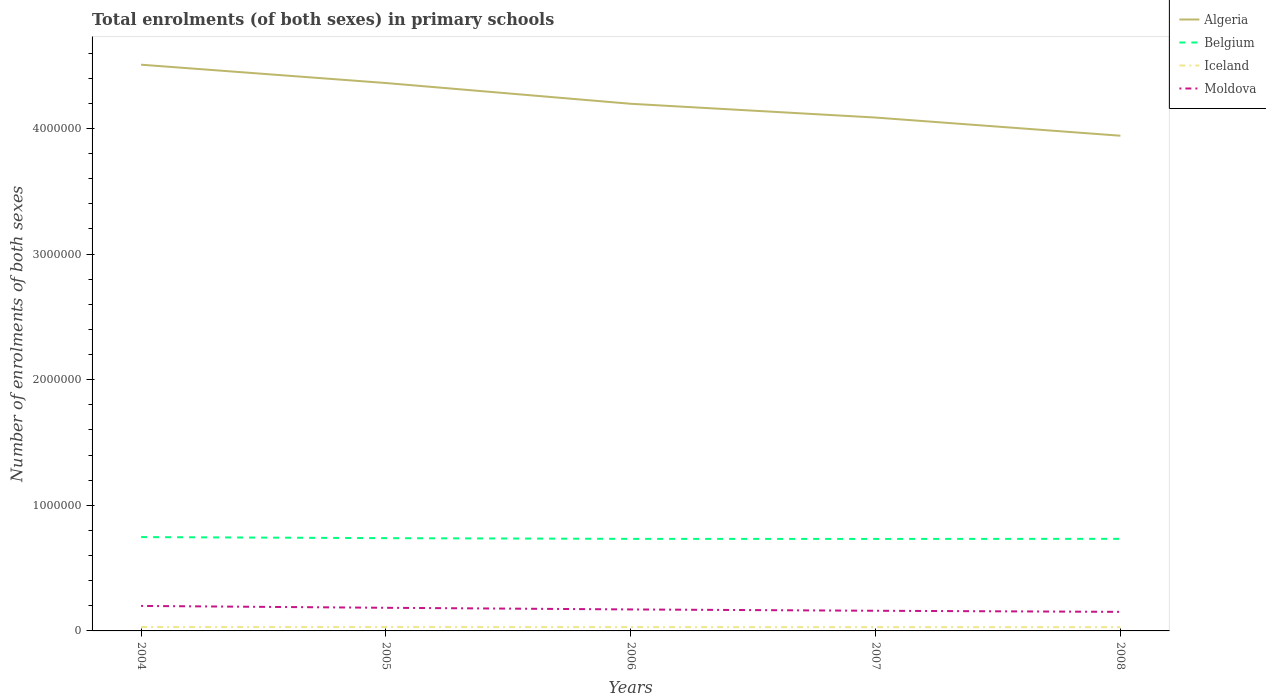Does the line corresponding to Iceland intersect with the line corresponding to Algeria?
Make the answer very short. No. Is the number of lines equal to the number of legend labels?
Keep it short and to the point. Yes. Across all years, what is the maximum number of enrolments in primary schools in Belgium?
Your answer should be very brief. 7.32e+05. In which year was the number of enrolments in primary schools in Belgium maximum?
Give a very brief answer. 2007. What is the total number of enrolments in primary schools in Iceland in the graph?
Your answer should be very brief. 1039. What is the difference between the highest and the second highest number of enrolments in primary schools in Belgium?
Offer a terse response. 1.47e+04. How many years are there in the graph?
Keep it short and to the point. 5. Are the values on the major ticks of Y-axis written in scientific E-notation?
Ensure brevity in your answer.  No. Does the graph contain any zero values?
Provide a succinct answer. No. Does the graph contain grids?
Your answer should be very brief. No. How many legend labels are there?
Keep it short and to the point. 4. How are the legend labels stacked?
Provide a succinct answer. Vertical. What is the title of the graph?
Give a very brief answer. Total enrolments (of both sexes) in primary schools. What is the label or title of the Y-axis?
Your answer should be compact. Number of enrolments of both sexes. What is the Number of enrolments of both sexes in Algeria in 2004?
Make the answer very short. 4.51e+06. What is the Number of enrolments of both sexes in Belgium in 2004?
Keep it short and to the point. 7.47e+05. What is the Number of enrolments of both sexes in Iceland in 2004?
Keep it short and to the point. 3.10e+04. What is the Number of enrolments of both sexes of Moldova in 2004?
Your answer should be very brief. 1.99e+05. What is the Number of enrolments of both sexes of Algeria in 2005?
Your response must be concise. 4.36e+06. What is the Number of enrolments of both sexes of Belgium in 2005?
Give a very brief answer. 7.39e+05. What is the Number of enrolments of both sexes in Iceland in 2005?
Make the answer very short. 3.08e+04. What is the Number of enrolments of both sexes in Moldova in 2005?
Give a very brief answer. 1.84e+05. What is the Number of enrolments of both sexes in Algeria in 2006?
Ensure brevity in your answer.  4.20e+06. What is the Number of enrolments of both sexes in Belgium in 2006?
Give a very brief answer. 7.33e+05. What is the Number of enrolments of both sexes in Iceland in 2006?
Provide a short and direct response. 3.04e+04. What is the Number of enrolments of both sexes in Moldova in 2006?
Your response must be concise. 1.71e+05. What is the Number of enrolments of both sexes in Algeria in 2007?
Give a very brief answer. 4.09e+06. What is the Number of enrolments of both sexes of Belgium in 2007?
Offer a terse response. 7.32e+05. What is the Number of enrolments of both sexes in Iceland in 2007?
Your answer should be very brief. 3.01e+04. What is the Number of enrolments of both sexes of Moldova in 2007?
Make the answer very short. 1.61e+05. What is the Number of enrolments of both sexes of Algeria in 2008?
Provide a short and direct response. 3.94e+06. What is the Number of enrolments of both sexes in Belgium in 2008?
Offer a terse response. 7.33e+05. What is the Number of enrolments of both sexes in Iceland in 2008?
Your answer should be compact. 2.99e+04. What is the Number of enrolments of both sexes of Moldova in 2008?
Offer a terse response. 1.52e+05. Across all years, what is the maximum Number of enrolments of both sexes in Algeria?
Ensure brevity in your answer.  4.51e+06. Across all years, what is the maximum Number of enrolments of both sexes in Belgium?
Keep it short and to the point. 7.47e+05. Across all years, what is the maximum Number of enrolments of both sexes of Iceland?
Your response must be concise. 3.10e+04. Across all years, what is the maximum Number of enrolments of both sexes of Moldova?
Keep it short and to the point. 1.99e+05. Across all years, what is the minimum Number of enrolments of both sexes of Algeria?
Your answer should be compact. 3.94e+06. Across all years, what is the minimum Number of enrolments of both sexes in Belgium?
Your answer should be very brief. 7.32e+05. Across all years, what is the minimum Number of enrolments of both sexes of Iceland?
Make the answer very short. 2.99e+04. Across all years, what is the minimum Number of enrolments of both sexes in Moldova?
Your response must be concise. 1.52e+05. What is the total Number of enrolments of both sexes in Algeria in the graph?
Ensure brevity in your answer.  2.11e+07. What is the total Number of enrolments of both sexes in Belgium in the graph?
Your answer should be very brief. 3.68e+06. What is the total Number of enrolments of both sexes of Iceland in the graph?
Your answer should be compact. 1.52e+05. What is the total Number of enrolments of both sexes of Moldova in the graph?
Your answer should be compact. 8.66e+05. What is the difference between the Number of enrolments of both sexes in Algeria in 2004 and that in 2005?
Ensure brevity in your answer.  1.46e+05. What is the difference between the Number of enrolments of both sexes of Belgium in 2004 and that in 2005?
Keep it short and to the point. 8531. What is the difference between the Number of enrolments of both sexes of Iceland in 2004 and that in 2005?
Offer a very short reply. 199. What is the difference between the Number of enrolments of both sexes of Moldova in 2004 and that in 2005?
Provide a short and direct response. 1.48e+04. What is the difference between the Number of enrolments of both sexes in Algeria in 2004 and that in 2006?
Provide a short and direct response. 3.11e+05. What is the difference between the Number of enrolments of both sexes in Belgium in 2004 and that in 2006?
Keep it short and to the point. 1.43e+04. What is the difference between the Number of enrolments of both sexes in Iceland in 2004 and that in 2006?
Your answer should be very brief. 563. What is the difference between the Number of enrolments of both sexes of Moldova in 2004 and that in 2006?
Offer a very short reply. 2.79e+04. What is the difference between the Number of enrolments of both sexes in Algeria in 2004 and that in 2007?
Offer a terse response. 4.21e+05. What is the difference between the Number of enrolments of both sexes of Belgium in 2004 and that in 2007?
Your response must be concise. 1.47e+04. What is the difference between the Number of enrolments of both sexes of Iceland in 2004 and that in 2007?
Give a very brief answer. 900. What is the difference between the Number of enrolments of both sexes in Moldova in 2004 and that in 2007?
Provide a succinct answer. 3.84e+04. What is the difference between the Number of enrolments of both sexes of Algeria in 2004 and that in 2008?
Offer a very short reply. 5.65e+05. What is the difference between the Number of enrolments of both sexes of Belgium in 2004 and that in 2008?
Keep it short and to the point. 1.41e+04. What is the difference between the Number of enrolments of both sexes of Iceland in 2004 and that in 2008?
Give a very brief answer. 1039. What is the difference between the Number of enrolments of both sexes in Moldova in 2004 and that in 2008?
Provide a short and direct response. 4.72e+04. What is the difference between the Number of enrolments of both sexes of Algeria in 2005 and that in 2006?
Offer a very short reply. 1.65e+05. What is the difference between the Number of enrolments of both sexes in Belgium in 2005 and that in 2006?
Your answer should be compact. 5772. What is the difference between the Number of enrolments of both sexes of Iceland in 2005 and that in 2006?
Provide a succinct answer. 364. What is the difference between the Number of enrolments of both sexes of Moldova in 2005 and that in 2006?
Make the answer very short. 1.31e+04. What is the difference between the Number of enrolments of both sexes of Algeria in 2005 and that in 2007?
Provide a succinct answer. 2.75e+05. What is the difference between the Number of enrolments of both sexes in Belgium in 2005 and that in 2007?
Keep it short and to the point. 6169. What is the difference between the Number of enrolments of both sexes of Iceland in 2005 and that in 2007?
Your answer should be very brief. 701. What is the difference between the Number of enrolments of both sexes in Moldova in 2005 and that in 2007?
Provide a succinct answer. 2.36e+04. What is the difference between the Number of enrolments of both sexes in Algeria in 2005 and that in 2008?
Ensure brevity in your answer.  4.20e+05. What is the difference between the Number of enrolments of both sexes in Belgium in 2005 and that in 2008?
Provide a short and direct response. 5528. What is the difference between the Number of enrolments of both sexes in Iceland in 2005 and that in 2008?
Give a very brief answer. 840. What is the difference between the Number of enrolments of both sexes in Moldova in 2005 and that in 2008?
Provide a short and direct response. 3.24e+04. What is the difference between the Number of enrolments of both sexes in Algeria in 2006 and that in 2007?
Your answer should be very brief. 1.10e+05. What is the difference between the Number of enrolments of both sexes in Belgium in 2006 and that in 2007?
Offer a terse response. 397. What is the difference between the Number of enrolments of both sexes of Iceland in 2006 and that in 2007?
Keep it short and to the point. 337. What is the difference between the Number of enrolments of both sexes in Moldova in 2006 and that in 2007?
Make the answer very short. 1.05e+04. What is the difference between the Number of enrolments of both sexes in Algeria in 2006 and that in 2008?
Provide a succinct answer. 2.54e+05. What is the difference between the Number of enrolments of both sexes of Belgium in 2006 and that in 2008?
Your answer should be very brief. -244. What is the difference between the Number of enrolments of both sexes in Iceland in 2006 and that in 2008?
Keep it short and to the point. 476. What is the difference between the Number of enrolments of both sexes in Moldova in 2006 and that in 2008?
Your answer should be compact. 1.93e+04. What is the difference between the Number of enrolments of both sexes in Algeria in 2007 and that in 2008?
Give a very brief answer. 1.45e+05. What is the difference between the Number of enrolments of both sexes in Belgium in 2007 and that in 2008?
Provide a short and direct response. -641. What is the difference between the Number of enrolments of both sexes in Iceland in 2007 and that in 2008?
Keep it short and to the point. 139. What is the difference between the Number of enrolments of both sexes of Moldova in 2007 and that in 2008?
Provide a succinct answer. 8792. What is the difference between the Number of enrolments of both sexes of Algeria in 2004 and the Number of enrolments of both sexes of Belgium in 2005?
Provide a short and direct response. 3.77e+06. What is the difference between the Number of enrolments of both sexes of Algeria in 2004 and the Number of enrolments of both sexes of Iceland in 2005?
Offer a terse response. 4.48e+06. What is the difference between the Number of enrolments of both sexes of Algeria in 2004 and the Number of enrolments of both sexes of Moldova in 2005?
Make the answer very short. 4.32e+06. What is the difference between the Number of enrolments of both sexes of Belgium in 2004 and the Number of enrolments of both sexes of Iceland in 2005?
Make the answer very short. 7.16e+05. What is the difference between the Number of enrolments of both sexes in Belgium in 2004 and the Number of enrolments of both sexes in Moldova in 2005?
Your response must be concise. 5.63e+05. What is the difference between the Number of enrolments of both sexes of Iceland in 2004 and the Number of enrolments of both sexes of Moldova in 2005?
Your answer should be very brief. -1.53e+05. What is the difference between the Number of enrolments of both sexes in Algeria in 2004 and the Number of enrolments of both sexes in Belgium in 2006?
Keep it short and to the point. 3.77e+06. What is the difference between the Number of enrolments of both sexes of Algeria in 2004 and the Number of enrolments of both sexes of Iceland in 2006?
Your response must be concise. 4.48e+06. What is the difference between the Number of enrolments of both sexes in Algeria in 2004 and the Number of enrolments of both sexes in Moldova in 2006?
Your answer should be very brief. 4.34e+06. What is the difference between the Number of enrolments of both sexes of Belgium in 2004 and the Number of enrolments of both sexes of Iceland in 2006?
Ensure brevity in your answer.  7.17e+05. What is the difference between the Number of enrolments of both sexes of Belgium in 2004 and the Number of enrolments of both sexes of Moldova in 2006?
Your answer should be compact. 5.76e+05. What is the difference between the Number of enrolments of both sexes in Iceland in 2004 and the Number of enrolments of both sexes in Moldova in 2006?
Make the answer very short. -1.40e+05. What is the difference between the Number of enrolments of both sexes of Algeria in 2004 and the Number of enrolments of both sexes of Belgium in 2007?
Provide a short and direct response. 3.78e+06. What is the difference between the Number of enrolments of both sexes of Algeria in 2004 and the Number of enrolments of both sexes of Iceland in 2007?
Your answer should be very brief. 4.48e+06. What is the difference between the Number of enrolments of both sexes of Algeria in 2004 and the Number of enrolments of both sexes of Moldova in 2007?
Offer a very short reply. 4.35e+06. What is the difference between the Number of enrolments of both sexes of Belgium in 2004 and the Number of enrolments of both sexes of Iceland in 2007?
Ensure brevity in your answer.  7.17e+05. What is the difference between the Number of enrolments of both sexes of Belgium in 2004 and the Number of enrolments of both sexes of Moldova in 2007?
Offer a terse response. 5.87e+05. What is the difference between the Number of enrolments of both sexes of Iceland in 2004 and the Number of enrolments of both sexes of Moldova in 2007?
Your answer should be compact. -1.30e+05. What is the difference between the Number of enrolments of both sexes of Algeria in 2004 and the Number of enrolments of both sexes of Belgium in 2008?
Offer a terse response. 3.77e+06. What is the difference between the Number of enrolments of both sexes of Algeria in 2004 and the Number of enrolments of both sexes of Iceland in 2008?
Make the answer very short. 4.48e+06. What is the difference between the Number of enrolments of both sexes of Algeria in 2004 and the Number of enrolments of both sexes of Moldova in 2008?
Provide a short and direct response. 4.36e+06. What is the difference between the Number of enrolments of both sexes of Belgium in 2004 and the Number of enrolments of both sexes of Iceland in 2008?
Provide a short and direct response. 7.17e+05. What is the difference between the Number of enrolments of both sexes in Belgium in 2004 and the Number of enrolments of both sexes in Moldova in 2008?
Keep it short and to the point. 5.95e+05. What is the difference between the Number of enrolments of both sexes in Iceland in 2004 and the Number of enrolments of both sexes in Moldova in 2008?
Give a very brief answer. -1.21e+05. What is the difference between the Number of enrolments of both sexes of Algeria in 2005 and the Number of enrolments of both sexes of Belgium in 2006?
Your response must be concise. 3.63e+06. What is the difference between the Number of enrolments of both sexes in Algeria in 2005 and the Number of enrolments of both sexes in Iceland in 2006?
Your response must be concise. 4.33e+06. What is the difference between the Number of enrolments of both sexes of Algeria in 2005 and the Number of enrolments of both sexes of Moldova in 2006?
Your answer should be compact. 4.19e+06. What is the difference between the Number of enrolments of both sexes in Belgium in 2005 and the Number of enrolments of both sexes in Iceland in 2006?
Provide a short and direct response. 7.08e+05. What is the difference between the Number of enrolments of both sexes of Belgium in 2005 and the Number of enrolments of both sexes of Moldova in 2006?
Your answer should be very brief. 5.68e+05. What is the difference between the Number of enrolments of both sexes in Iceland in 2005 and the Number of enrolments of both sexes in Moldova in 2006?
Make the answer very short. -1.40e+05. What is the difference between the Number of enrolments of both sexes in Algeria in 2005 and the Number of enrolments of both sexes in Belgium in 2007?
Provide a succinct answer. 3.63e+06. What is the difference between the Number of enrolments of both sexes of Algeria in 2005 and the Number of enrolments of both sexes of Iceland in 2007?
Your response must be concise. 4.33e+06. What is the difference between the Number of enrolments of both sexes of Algeria in 2005 and the Number of enrolments of both sexes of Moldova in 2007?
Provide a succinct answer. 4.20e+06. What is the difference between the Number of enrolments of both sexes in Belgium in 2005 and the Number of enrolments of both sexes in Iceland in 2007?
Ensure brevity in your answer.  7.08e+05. What is the difference between the Number of enrolments of both sexes of Belgium in 2005 and the Number of enrolments of both sexes of Moldova in 2007?
Provide a succinct answer. 5.78e+05. What is the difference between the Number of enrolments of both sexes in Iceland in 2005 and the Number of enrolments of both sexes in Moldova in 2007?
Offer a very short reply. -1.30e+05. What is the difference between the Number of enrolments of both sexes in Algeria in 2005 and the Number of enrolments of both sexes in Belgium in 2008?
Your answer should be very brief. 3.63e+06. What is the difference between the Number of enrolments of both sexes in Algeria in 2005 and the Number of enrolments of both sexes in Iceland in 2008?
Give a very brief answer. 4.33e+06. What is the difference between the Number of enrolments of both sexes in Algeria in 2005 and the Number of enrolments of both sexes in Moldova in 2008?
Give a very brief answer. 4.21e+06. What is the difference between the Number of enrolments of both sexes of Belgium in 2005 and the Number of enrolments of both sexes of Iceland in 2008?
Give a very brief answer. 7.09e+05. What is the difference between the Number of enrolments of both sexes of Belgium in 2005 and the Number of enrolments of both sexes of Moldova in 2008?
Your answer should be very brief. 5.87e+05. What is the difference between the Number of enrolments of both sexes of Iceland in 2005 and the Number of enrolments of both sexes of Moldova in 2008?
Provide a succinct answer. -1.21e+05. What is the difference between the Number of enrolments of both sexes in Algeria in 2006 and the Number of enrolments of both sexes in Belgium in 2007?
Your response must be concise. 3.46e+06. What is the difference between the Number of enrolments of both sexes of Algeria in 2006 and the Number of enrolments of both sexes of Iceland in 2007?
Provide a short and direct response. 4.17e+06. What is the difference between the Number of enrolments of both sexes of Algeria in 2006 and the Number of enrolments of both sexes of Moldova in 2007?
Offer a terse response. 4.04e+06. What is the difference between the Number of enrolments of both sexes in Belgium in 2006 and the Number of enrolments of both sexes in Iceland in 2007?
Keep it short and to the point. 7.03e+05. What is the difference between the Number of enrolments of both sexes of Belgium in 2006 and the Number of enrolments of both sexes of Moldova in 2007?
Ensure brevity in your answer.  5.72e+05. What is the difference between the Number of enrolments of both sexes of Iceland in 2006 and the Number of enrolments of both sexes of Moldova in 2007?
Your answer should be very brief. -1.30e+05. What is the difference between the Number of enrolments of both sexes in Algeria in 2006 and the Number of enrolments of both sexes in Belgium in 2008?
Ensure brevity in your answer.  3.46e+06. What is the difference between the Number of enrolments of both sexes of Algeria in 2006 and the Number of enrolments of both sexes of Iceland in 2008?
Offer a terse response. 4.17e+06. What is the difference between the Number of enrolments of both sexes of Algeria in 2006 and the Number of enrolments of both sexes of Moldova in 2008?
Ensure brevity in your answer.  4.04e+06. What is the difference between the Number of enrolments of both sexes in Belgium in 2006 and the Number of enrolments of both sexes in Iceland in 2008?
Keep it short and to the point. 7.03e+05. What is the difference between the Number of enrolments of both sexes of Belgium in 2006 and the Number of enrolments of both sexes of Moldova in 2008?
Keep it short and to the point. 5.81e+05. What is the difference between the Number of enrolments of both sexes of Iceland in 2006 and the Number of enrolments of both sexes of Moldova in 2008?
Your answer should be very brief. -1.21e+05. What is the difference between the Number of enrolments of both sexes in Algeria in 2007 and the Number of enrolments of both sexes in Belgium in 2008?
Provide a succinct answer. 3.35e+06. What is the difference between the Number of enrolments of both sexes of Algeria in 2007 and the Number of enrolments of both sexes of Iceland in 2008?
Your answer should be compact. 4.06e+06. What is the difference between the Number of enrolments of both sexes in Algeria in 2007 and the Number of enrolments of both sexes in Moldova in 2008?
Make the answer very short. 3.94e+06. What is the difference between the Number of enrolments of both sexes in Belgium in 2007 and the Number of enrolments of both sexes in Iceland in 2008?
Your response must be concise. 7.02e+05. What is the difference between the Number of enrolments of both sexes of Belgium in 2007 and the Number of enrolments of both sexes of Moldova in 2008?
Offer a terse response. 5.81e+05. What is the difference between the Number of enrolments of both sexes in Iceland in 2007 and the Number of enrolments of both sexes in Moldova in 2008?
Your response must be concise. -1.22e+05. What is the average Number of enrolments of both sexes of Algeria per year?
Provide a short and direct response. 4.22e+06. What is the average Number of enrolments of both sexes of Belgium per year?
Offer a very short reply. 7.37e+05. What is the average Number of enrolments of both sexes of Iceland per year?
Provide a short and direct response. 3.04e+04. What is the average Number of enrolments of both sexes of Moldova per year?
Provide a short and direct response. 1.73e+05. In the year 2004, what is the difference between the Number of enrolments of both sexes in Algeria and Number of enrolments of both sexes in Belgium?
Give a very brief answer. 3.76e+06. In the year 2004, what is the difference between the Number of enrolments of both sexes in Algeria and Number of enrolments of both sexes in Iceland?
Provide a short and direct response. 4.48e+06. In the year 2004, what is the difference between the Number of enrolments of both sexes in Algeria and Number of enrolments of both sexes in Moldova?
Provide a short and direct response. 4.31e+06. In the year 2004, what is the difference between the Number of enrolments of both sexes of Belgium and Number of enrolments of both sexes of Iceland?
Give a very brief answer. 7.16e+05. In the year 2004, what is the difference between the Number of enrolments of both sexes of Belgium and Number of enrolments of both sexes of Moldova?
Make the answer very short. 5.48e+05. In the year 2004, what is the difference between the Number of enrolments of both sexes in Iceland and Number of enrolments of both sexes in Moldova?
Provide a short and direct response. -1.68e+05. In the year 2005, what is the difference between the Number of enrolments of both sexes in Algeria and Number of enrolments of both sexes in Belgium?
Provide a succinct answer. 3.62e+06. In the year 2005, what is the difference between the Number of enrolments of both sexes in Algeria and Number of enrolments of both sexes in Iceland?
Your answer should be compact. 4.33e+06. In the year 2005, what is the difference between the Number of enrolments of both sexes of Algeria and Number of enrolments of both sexes of Moldova?
Your answer should be compact. 4.18e+06. In the year 2005, what is the difference between the Number of enrolments of both sexes of Belgium and Number of enrolments of both sexes of Iceland?
Your response must be concise. 7.08e+05. In the year 2005, what is the difference between the Number of enrolments of both sexes of Belgium and Number of enrolments of both sexes of Moldova?
Your answer should be very brief. 5.54e+05. In the year 2005, what is the difference between the Number of enrolments of both sexes in Iceland and Number of enrolments of both sexes in Moldova?
Offer a terse response. -1.53e+05. In the year 2006, what is the difference between the Number of enrolments of both sexes of Algeria and Number of enrolments of both sexes of Belgium?
Provide a succinct answer. 3.46e+06. In the year 2006, what is the difference between the Number of enrolments of both sexes in Algeria and Number of enrolments of both sexes in Iceland?
Offer a very short reply. 4.17e+06. In the year 2006, what is the difference between the Number of enrolments of both sexes in Algeria and Number of enrolments of both sexes in Moldova?
Offer a terse response. 4.03e+06. In the year 2006, what is the difference between the Number of enrolments of both sexes in Belgium and Number of enrolments of both sexes in Iceland?
Your answer should be compact. 7.02e+05. In the year 2006, what is the difference between the Number of enrolments of both sexes of Belgium and Number of enrolments of both sexes of Moldova?
Ensure brevity in your answer.  5.62e+05. In the year 2006, what is the difference between the Number of enrolments of both sexes of Iceland and Number of enrolments of both sexes of Moldova?
Give a very brief answer. -1.41e+05. In the year 2007, what is the difference between the Number of enrolments of both sexes in Algeria and Number of enrolments of both sexes in Belgium?
Provide a succinct answer. 3.35e+06. In the year 2007, what is the difference between the Number of enrolments of both sexes in Algeria and Number of enrolments of both sexes in Iceland?
Your answer should be compact. 4.06e+06. In the year 2007, what is the difference between the Number of enrolments of both sexes of Algeria and Number of enrolments of both sexes of Moldova?
Give a very brief answer. 3.93e+06. In the year 2007, what is the difference between the Number of enrolments of both sexes in Belgium and Number of enrolments of both sexes in Iceland?
Ensure brevity in your answer.  7.02e+05. In the year 2007, what is the difference between the Number of enrolments of both sexes of Belgium and Number of enrolments of both sexes of Moldova?
Provide a short and direct response. 5.72e+05. In the year 2007, what is the difference between the Number of enrolments of both sexes of Iceland and Number of enrolments of both sexes of Moldova?
Ensure brevity in your answer.  -1.30e+05. In the year 2008, what is the difference between the Number of enrolments of both sexes in Algeria and Number of enrolments of both sexes in Belgium?
Offer a terse response. 3.21e+06. In the year 2008, what is the difference between the Number of enrolments of both sexes of Algeria and Number of enrolments of both sexes of Iceland?
Ensure brevity in your answer.  3.91e+06. In the year 2008, what is the difference between the Number of enrolments of both sexes of Algeria and Number of enrolments of both sexes of Moldova?
Keep it short and to the point. 3.79e+06. In the year 2008, what is the difference between the Number of enrolments of both sexes of Belgium and Number of enrolments of both sexes of Iceland?
Make the answer very short. 7.03e+05. In the year 2008, what is the difference between the Number of enrolments of both sexes of Belgium and Number of enrolments of both sexes of Moldova?
Your response must be concise. 5.81e+05. In the year 2008, what is the difference between the Number of enrolments of both sexes of Iceland and Number of enrolments of both sexes of Moldova?
Offer a terse response. -1.22e+05. What is the ratio of the Number of enrolments of both sexes in Algeria in 2004 to that in 2005?
Make the answer very short. 1.03. What is the ratio of the Number of enrolments of both sexes of Belgium in 2004 to that in 2005?
Your answer should be very brief. 1.01. What is the ratio of the Number of enrolments of both sexes of Iceland in 2004 to that in 2005?
Offer a very short reply. 1.01. What is the ratio of the Number of enrolments of both sexes in Moldova in 2004 to that in 2005?
Your response must be concise. 1.08. What is the ratio of the Number of enrolments of both sexes of Algeria in 2004 to that in 2006?
Keep it short and to the point. 1.07. What is the ratio of the Number of enrolments of both sexes of Belgium in 2004 to that in 2006?
Keep it short and to the point. 1.02. What is the ratio of the Number of enrolments of both sexes in Iceland in 2004 to that in 2006?
Provide a succinct answer. 1.02. What is the ratio of the Number of enrolments of both sexes of Moldova in 2004 to that in 2006?
Provide a succinct answer. 1.16. What is the ratio of the Number of enrolments of both sexes of Algeria in 2004 to that in 2007?
Your response must be concise. 1.1. What is the ratio of the Number of enrolments of both sexes of Belgium in 2004 to that in 2007?
Your response must be concise. 1.02. What is the ratio of the Number of enrolments of both sexes in Iceland in 2004 to that in 2007?
Your answer should be compact. 1.03. What is the ratio of the Number of enrolments of both sexes in Moldova in 2004 to that in 2007?
Your answer should be very brief. 1.24. What is the ratio of the Number of enrolments of both sexes of Algeria in 2004 to that in 2008?
Offer a very short reply. 1.14. What is the ratio of the Number of enrolments of both sexes of Belgium in 2004 to that in 2008?
Give a very brief answer. 1.02. What is the ratio of the Number of enrolments of both sexes of Iceland in 2004 to that in 2008?
Make the answer very short. 1.03. What is the ratio of the Number of enrolments of both sexes of Moldova in 2004 to that in 2008?
Make the answer very short. 1.31. What is the ratio of the Number of enrolments of both sexes of Algeria in 2005 to that in 2006?
Provide a short and direct response. 1.04. What is the ratio of the Number of enrolments of both sexes of Belgium in 2005 to that in 2006?
Your answer should be compact. 1.01. What is the ratio of the Number of enrolments of both sexes in Iceland in 2005 to that in 2006?
Give a very brief answer. 1.01. What is the ratio of the Number of enrolments of both sexes of Moldova in 2005 to that in 2006?
Make the answer very short. 1.08. What is the ratio of the Number of enrolments of both sexes of Algeria in 2005 to that in 2007?
Offer a terse response. 1.07. What is the ratio of the Number of enrolments of both sexes in Belgium in 2005 to that in 2007?
Make the answer very short. 1.01. What is the ratio of the Number of enrolments of both sexes in Iceland in 2005 to that in 2007?
Offer a very short reply. 1.02. What is the ratio of the Number of enrolments of both sexes in Moldova in 2005 to that in 2007?
Offer a very short reply. 1.15. What is the ratio of the Number of enrolments of both sexes in Algeria in 2005 to that in 2008?
Your answer should be very brief. 1.11. What is the ratio of the Number of enrolments of both sexes of Belgium in 2005 to that in 2008?
Offer a terse response. 1.01. What is the ratio of the Number of enrolments of both sexes of Iceland in 2005 to that in 2008?
Offer a terse response. 1.03. What is the ratio of the Number of enrolments of both sexes in Moldova in 2005 to that in 2008?
Ensure brevity in your answer.  1.21. What is the ratio of the Number of enrolments of both sexes of Algeria in 2006 to that in 2007?
Your response must be concise. 1.03. What is the ratio of the Number of enrolments of both sexes in Iceland in 2006 to that in 2007?
Keep it short and to the point. 1.01. What is the ratio of the Number of enrolments of both sexes of Moldova in 2006 to that in 2007?
Your response must be concise. 1.07. What is the ratio of the Number of enrolments of both sexes in Algeria in 2006 to that in 2008?
Ensure brevity in your answer.  1.06. What is the ratio of the Number of enrolments of both sexes in Iceland in 2006 to that in 2008?
Offer a very short reply. 1.02. What is the ratio of the Number of enrolments of both sexes in Moldova in 2006 to that in 2008?
Provide a short and direct response. 1.13. What is the ratio of the Number of enrolments of both sexes in Algeria in 2007 to that in 2008?
Ensure brevity in your answer.  1.04. What is the ratio of the Number of enrolments of both sexes in Iceland in 2007 to that in 2008?
Ensure brevity in your answer.  1. What is the ratio of the Number of enrolments of both sexes of Moldova in 2007 to that in 2008?
Ensure brevity in your answer.  1.06. What is the difference between the highest and the second highest Number of enrolments of both sexes of Algeria?
Provide a succinct answer. 1.46e+05. What is the difference between the highest and the second highest Number of enrolments of both sexes in Belgium?
Your answer should be very brief. 8531. What is the difference between the highest and the second highest Number of enrolments of both sexes of Iceland?
Ensure brevity in your answer.  199. What is the difference between the highest and the second highest Number of enrolments of both sexes of Moldova?
Provide a short and direct response. 1.48e+04. What is the difference between the highest and the lowest Number of enrolments of both sexes in Algeria?
Your response must be concise. 5.65e+05. What is the difference between the highest and the lowest Number of enrolments of both sexes of Belgium?
Ensure brevity in your answer.  1.47e+04. What is the difference between the highest and the lowest Number of enrolments of both sexes in Iceland?
Provide a short and direct response. 1039. What is the difference between the highest and the lowest Number of enrolments of both sexes of Moldova?
Provide a short and direct response. 4.72e+04. 